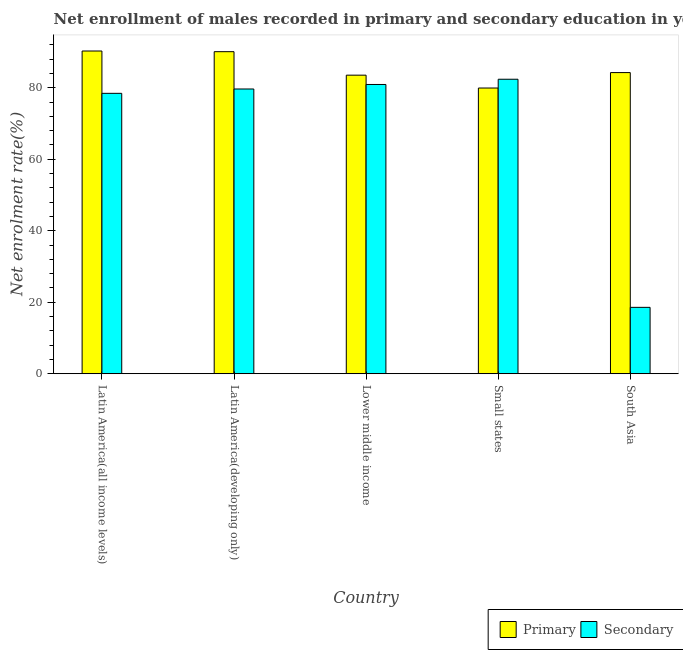How many different coloured bars are there?
Your answer should be compact. 2. Are the number of bars on each tick of the X-axis equal?
Give a very brief answer. Yes. How many bars are there on the 4th tick from the right?
Your answer should be compact. 2. What is the label of the 3rd group of bars from the left?
Offer a very short reply. Lower middle income. What is the enrollment rate in primary education in South Asia?
Provide a succinct answer. 84.25. Across all countries, what is the maximum enrollment rate in secondary education?
Provide a succinct answer. 82.39. Across all countries, what is the minimum enrollment rate in secondary education?
Your answer should be very brief. 18.57. In which country was the enrollment rate in primary education maximum?
Provide a short and direct response. Latin America(all income levels). In which country was the enrollment rate in secondary education minimum?
Your answer should be compact. South Asia. What is the total enrollment rate in secondary education in the graph?
Provide a short and direct response. 340. What is the difference between the enrollment rate in secondary education in Latin America(all income levels) and that in Lower middle income?
Your answer should be very brief. -2.48. What is the difference between the enrollment rate in primary education in Latin America(all income levels) and the enrollment rate in secondary education in Latin America(developing only)?
Offer a terse response. 10.63. What is the average enrollment rate in primary education per country?
Provide a succinct answer. 85.62. What is the difference between the enrollment rate in primary education and enrollment rate in secondary education in South Asia?
Your answer should be compact. 65.68. What is the ratio of the enrollment rate in primary education in Latin America(all income levels) to that in Lower middle income?
Provide a succinct answer. 1.08. Is the enrollment rate in secondary education in Lower middle income less than that in South Asia?
Provide a succinct answer. No. Is the difference between the enrollment rate in secondary education in Lower middle income and Small states greater than the difference between the enrollment rate in primary education in Lower middle income and Small states?
Ensure brevity in your answer.  No. What is the difference between the highest and the second highest enrollment rate in primary education?
Make the answer very short. 0.19. What is the difference between the highest and the lowest enrollment rate in secondary education?
Offer a very short reply. 63.82. In how many countries, is the enrollment rate in primary education greater than the average enrollment rate in primary education taken over all countries?
Keep it short and to the point. 2. What does the 2nd bar from the left in Small states represents?
Your answer should be compact. Secondary. What does the 2nd bar from the right in Latin America(developing only) represents?
Give a very brief answer. Primary. How many bars are there?
Make the answer very short. 10. Are all the bars in the graph horizontal?
Give a very brief answer. No. Are the values on the major ticks of Y-axis written in scientific E-notation?
Give a very brief answer. No. Does the graph contain any zero values?
Give a very brief answer. No. Does the graph contain grids?
Your answer should be very brief. No. Where does the legend appear in the graph?
Your response must be concise. Bottom right. How are the legend labels stacked?
Give a very brief answer. Horizontal. What is the title of the graph?
Keep it short and to the point. Net enrollment of males recorded in primary and secondary education in year 1990. What is the label or title of the Y-axis?
Your response must be concise. Net enrolment rate(%). What is the Net enrolment rate(%) in Primary in Latin America(all income levels)?
Your answer should be compact. 90.29. What is the Net enrolment rate(%) in Secondary in Latin America(all income levels)?
Your answer should be very brief. 78.45. What is the Net enrolment rate(%) in Primary in Latin America(developing only)?
Provide a short and direct response. 90.1. What is the Net enrolment rate(%) in Secondary in Latin America(developing only)?
Give a very brief answer. 79.66. What is the Net enrolment rate(%) of Primary in Lower middle income?
Your response must be concise. 83.53. What is the Net enrolment rate(%) of Secondary in Lower middle income?
Your answer should be compact. 80.93. What is the Net enrolment rate(%) in Primary in Small states?
Offer a very short reply. 79.93. What is the Net enrolment rate(%) of Secondary in Small states?
Provide a short and direct response. 82.39. What is the Net enrolment rate(%) of Primary in South Asia?
Keep it short and to the point. 84.25. What is the Net enrolment rate(%) of Secondary in South Asia?
Provide a succinct answer. 18.57. Across all countries, what is the maximum Net enrolment rate(%) of Primary?
Ensure brevity in your answer.  90.29. Across all countries, what is the maximum Net enrolment rate(%) in Secondary?
Provide a short and direct response. 82.39. Across all countries, what is the minimum Net enrolment rate(%) of Primary?
Make the answer very short. 79.93. Across all countries, what is the minimum Net enrolment rate(%) in Secondary?
Make the answer very short. 18.57. What is the total Net enrolment rate(%) of Primary in the graph?
Keep it short and to the point. 428.1. What is the total Net enrolment rate(%) of Secondary in the graph?
Offer a very short reply. 340. What is the difference between the Net enrolment rate(%) of Primary in Latin America(all income levels) and that in Latin America(developing only)?
Offer a very short reply. 0.19. What is the difference between the Net enrolment rate(%) of Secondary in Latin America(all income levels) and that in Latin America(developing only)?
Offer a terse response. -1.22. What is the difference between the Net enrolment rate(%) of Primary in Latin America(all income levels) and that in Lower middle income?
Offer a terse response. 6.76. What is the difference between the Net enrolment rate(%) in Secondary in Latin America(all income levels) and that in Lower middle income?
Provide a short and direct response. -2.48. What is the difference between the Net enrolment rate(%) of Primary in Latin America(all income levels) and that in Small states?
Ensure brevity in your answer.  10.36. What is the difference between the Net enrolment rate(%) of Secondary in Latin America(all income levels) and that in Small states?
Provide a succinct answer. -3.94. What is the difference between the Net enrolment rate(%) in Primary in Latin America(all income levels) and that in South Asia?
Keep it short and to the point. 6.04. What is the difference between the Net enrolment rate(%) of Secondary in Latin America(all income levels) and that in South Asia?
Provide a short and direct response. 59.88. What is the difference between the Net enrolment rate(%) in Primary in Latin America(developing only) and that in Lower middle income?
Your answer should be compact. 6.57. What is the difference between the Net enrolment rate(%) of Secondary in Latin America(developing only) and that in Lower middle income?
Ensure brevity in your answer.  -1.26. What is the difference between the Net enrolment rate(%) of Primary in Latin America(developing only) and that in Small states?
Keep it short and to the point. 10.17. What is the difference between the Net enrolment rate(%) of Secondary in Latin America(developing only) and that in Small states?
Keep it short and to the point. -2.73. What is the difference between the Net enrolment rate(%) in Primary in Latin America(developing only) and that in South Asia?
Ensure brevity in your answer.  5.85. What is the difference between the Net enrolment rate(%) of Secondary in Latin America(developing only) and that in South Asia?
Your answer should be compact. 61.09. What is the difference between the Net enrolment rate(%) in Primary in Lower middle income and that in Small states?
Your answer should be very brief. 3.6. What is the difference between the Net enrolment rate(%) of Secondary in Lower middle income and that in Small states?
Provide a succinct answer. -1.46. What is the difference between the Net enrolment rate(%) in Primary in Lower middle income and that in South Asia?
Your answer should be very brief. -0.72. What is the difference between the Net enrolment rate(%) in Secondary in Lower middle income and that in South Asia?
Provide a succinct answer. 62.36. What is the difference between the Net enrolment rate(%) in Primary in Small states and that in South Asia?
Provide a short and direct response. -4.32. What is the difference between the Net enrolment rate(%) of Secondary in Small states and that in South Asia?
Provide a short and direct response. 63.82. What is the difference between the Net enrolment rate(%) of Primary in Latin America(all income levels) and the Net enrolment rate(%) of Secondary in Latin America(developing only)?
Your answer should be compact. 10.63. What is the difference between the Net enrolment rate(%) of Primary in Latin America(all income levels) and the Net enrolment rate(%) of Secondary in Lower middle income?
Give a very brief answer. 9.36. What is the difference between the Net enrolment rate(%) in Primary in Latin America(all income levels) and the Net enrolment rate(%) in Secondary in Small states?
Give a very brief answer. 7.9. What is the difference between the Net enrolment rate(%) of Primary in Latin America(all income levels) and the Net enrolment rate(%) of Secondary in South Asia?
Provide a succinct answer. 71.72. What is the difference between the Net enrolment rate(%) in Primary in Latin America(developing only) and the Net enrolment rate(%) in Secondary in Lower middle income?
Give a very brief answer. 9.17. What is the difference between the Net enrolment rate(%) in Primary in Latin America(developing only) and the Net enrolment rate(%) in Secondary in Small states?
Provide a succinct answer. 7.71. What is the difference between the Net enrolment rate(%) in Primary in Latin America(developing only) and the Net enrolment rate(%) in Secondary in South Asia?
Make the answer very short. 71.53. What is the difference between the Net enrolment rate(%) of Primary in Lower middle income and the Net enrolment rate(%) of Secondary in Small states?
Offer a very short reply. 1.14. What is the difference between the Net enrolment rate(%) in Primary in Lower middle income and the Net enrolment rate(%) in Secondary in South Asia?
Provide a short and direct response. 64.96. What is the difference between the Net enrolment rate(%) of Primary in Small states and the Net enrolment rate(%) of Secondary in South Asia?
Your answer should be compact. 61.36. What is the average Net enrolment rate(%) in Primary per country?
Give a very brief answer. 85.62. What is the average Net enrolment rate(%) in Secondary per country?
Offer a terse response. 68. What is the difference between the Net enrolment rate(%) of Primary and Net enrolment rate(%) of Secondary in Latin America(all income levels)?
Keep it short and to the point. 11.84. What is the difference between the Net enrolment rate(%) of Primary and Net enrolment rate(%) of Secondary in Latin America(developing only)?
Your answer should be very brief. 10.44. What is the difference between the Net enrolment rate(%) in Primary and Net enrolment rate(%) in Secondary in Lower middle income?
Provide a short and direct response. 2.6. What is the difference between the Net enrolment rate(%) of Primary and Net enrolment rate(%) of Secondary in Small states?
Offer a terse response. -2.46. What is the difference between the Net enrolment rate(%) of Primary and Net enrolment rate(%) of Secondary in South Asia?
Provide a short and direct response. 65.68. What is the ratio of the Net enrolment rate(%) in Secondary in Latin America(all income levels) to that in Latin America(developing only)?
Your response must be concise. 0.98. What is the ratio of the Net enrolment rate(%) of Primary in Latin America(all income levels) to that in Lower middle income?
Your answer should be compact. 1.08. What is the ratio of the Net enrolment rate(%) in Secondary in Latin America(all income levels) to that in Lower middle income?
Offer a very short reply. 0.97. What is the ratio of the Net enrolment rate(%) in Primary in Latin America(all income levels) to that in Small states?
Provide a short and direct response. 1.13. What is the ratio of the Net enrolment rate(%) in Secondary in Latin America(all income levels) to that in Small states?
Offer a terse response. 0.95. What is the ratio of the Net enrolment rate(%) in Primary in Latin America(all income levels) to that in South Asia?
Ensure brevity in your answer.  1.07. What is the ratio of the Net enrolment rate(%) of Secondary in Latin America(all income levels) to that in South Asia?
Keep it short and to the point. 4.22. What is the ratio of the Net enrolment rate(%) in Primary in Latin America(developing only) to that in Lower middle income?
Your response must be concise. 1.08. What is the ratio of the Net enrolment rate(%) of Secondary in Latin America(developing only) to that in Lower middle income?
Make the answer very short. 0.98. What is the ratio of the Net enrolment rate(%) of Primary in Latin America(developing only) to that in Small states?
Give a very brief answer. 1.13. What is the ratio of the Net enrolment rate(%) of Secondary in Latin America(developing only) to that in Small states?
Provide a succinct answer. 0.97. What is the ratio of the Net enrolment rate(%) of Primary in Latin America(developing only) to that in South Asia?
Your answer should be compact. 1.07. What is the ratio of the Net enrolment rate(%) of Secondary in Latin America(developing only) to that in South Asia?
Offer a terse response. 4.29. What is the ratio of the Net enrolment rate(%) in Primary in Lower middle income to that in Small states?
Offer a very short reply. 1.04. What is the ratio of the Net enrolment rate(%) of Secondary in Lower middle income to that in Small states?
Offer a very short reply. 0.98. What is the ratio of the Net enrolment rate(%) in Primary in Lower middle income to that in South Asia?
Provide a short and direct response. 0.99. What is the ratio of the Net enrolment rate(%) of Secondary in Lower middle income to that in South Asia?
Give a very brief answer. 4.36. What is the ratio of the Net enrolment rate(%) of Primary in Small states to that in South Asia?
Keep it short and to the point. 0.95. What is the ratio of the Net enrolment rate(%) in Secondary in Small states to that in South Asia?
Make the answer very short. 4.44. What is the difference between the highest and the second highest Net enrolment rate(%) in Primary?
Ensure brevity in your answer.  0.19. What is the difference between the highest and the second highest Net enrolment rate(%) in Secondary?
Provide a succinct answer. 1.46. What is the difference between the highest and the lowest Net enrolment rate(%) of Primary?
Your answer should be very brief. 10.36. What is the difference between the highest and the lowest Net enrolment rate(%) in Secondary?
Ensure brevity in your answer.  63.82. 